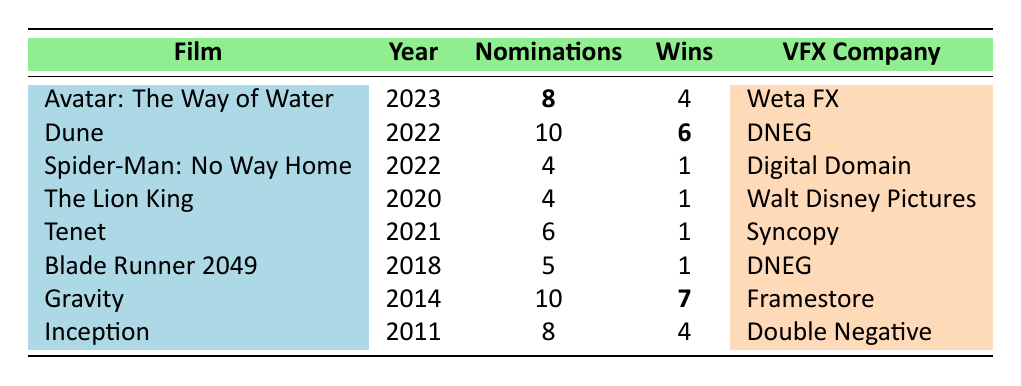What film has the highest number of award nominations? The film "Dune" has the highest number of award nominations with 10.
Answer: Dune How many awards did "Gravity" win? "Gravity" won a total of 7 awards.
Answer: 7 Which visual effects company worked on "Avatar: The Way of Water"? The visual effects company for "Avatar: The Way of Water" is Weta FX.
Answer: Weta FX Did "Blade Runner 2049" win more awards than "Tenet"? "Blade Runner 2049" won 1 award, while "Tenet" also won 1 award. Therefore, they won the same number of awards.
Answer: No What is the total number of awards nominated for all films listed in the table? To find this total, we add: 8 (Avatar) + 10 (Dune) + 4 (Spider-Man) + 4 (Lion King) + 6 (Tenet) + 5 (Blade Runner) + 10 (Gravity) + 8 (Inception) = 55.
Answer: 55 Which film won the most awards in the year 2022? "Dune" won the most awards in 2022, with a total of 6 wins.
Answer: Dune Is it true that "Inception" and "Avatar: The Way of Water" have the same number of awards won? "Inception" won 4 awards and "Avatar: The Way of Water" won 4 awards, so they have the same number of awards won.
Answer: Yes Provide the average number of awards won across all films listed in the table. The total number of wins is 4 (Avatar) + 6 (Dune) + 1 (Spider-Man) + 1 (Lion King) + 1 (Tenet) + 1 (Blade Runner) + 7 (Gravity) + 4 (Inception) = 26. There are 8 films, so the average is 26/8 = 3.25.
Answer: 3.25 What is the difference between the highest number of awards won and the lowest number of awards won? The highest number of awards won is 7 (Gravity) and the lowest is 1 (Spider-Man, Lion King, Tenet, Blade Runner), so the difference is 7 - 1 = 6.
Answer: 6 Which visual effects company is associated with the film "Dune"? The visual effects company associated with "Dune" is DNEG.
Answer: DNEG 